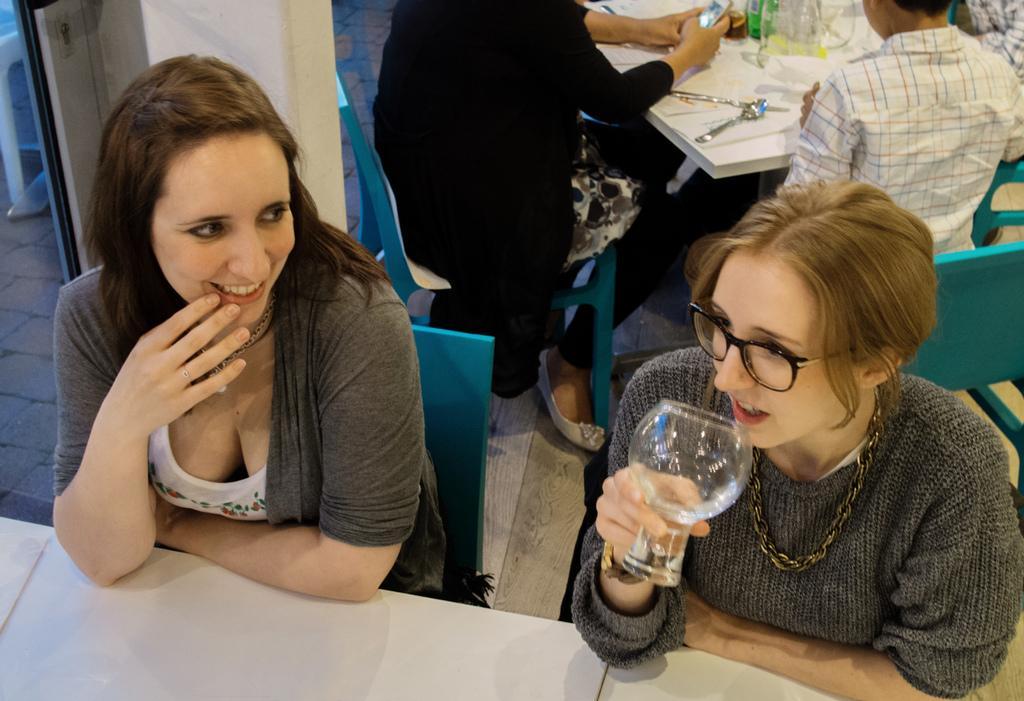In one or two sentences, can you explain what this image depicts? In this picture there are people sitting on chairs, among them there is a woman holding a glass. We can see tables and floor, on the table we can see objects on the table. 